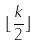Convert formula to latex. <formula><loc_0><loc_0><loc_500><loc_500>\lfloor \frac { k } { 2 } \rfloor</formula> 